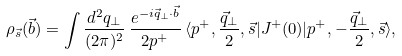Convert formula to latex. <formula><loc_0><loc_0><loc_500><loc_500>\rho _ { \vec { s } } ( \vec { b } ) = \int \frac { d ^ { 2 } q _ { \perp } } { ( 2 \pi ) ^ { 2 } } \, \frac { e ^ { - i \vec { q } _ { \perp } \cdot \vec { b } } } { 2 p ^ { + } } \, \langle p ^ { + } , \frac { \vec { q } _ { \perp } } { 2 } , \vec { s } | J ^ { + } ( 0 ) | p ^ { + } , - \frac { \vec { q } _ { \perp } } { 2 } , \vec { s } \rangle ,</formula> 